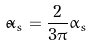Convert formula to latex. <formula><loc_0><loc_0><loc_500><loc_500>\tilde { \alpha } _ { s } = { \frac { 2 } { 3 \pi } } \alpha _ { s }</formula> 